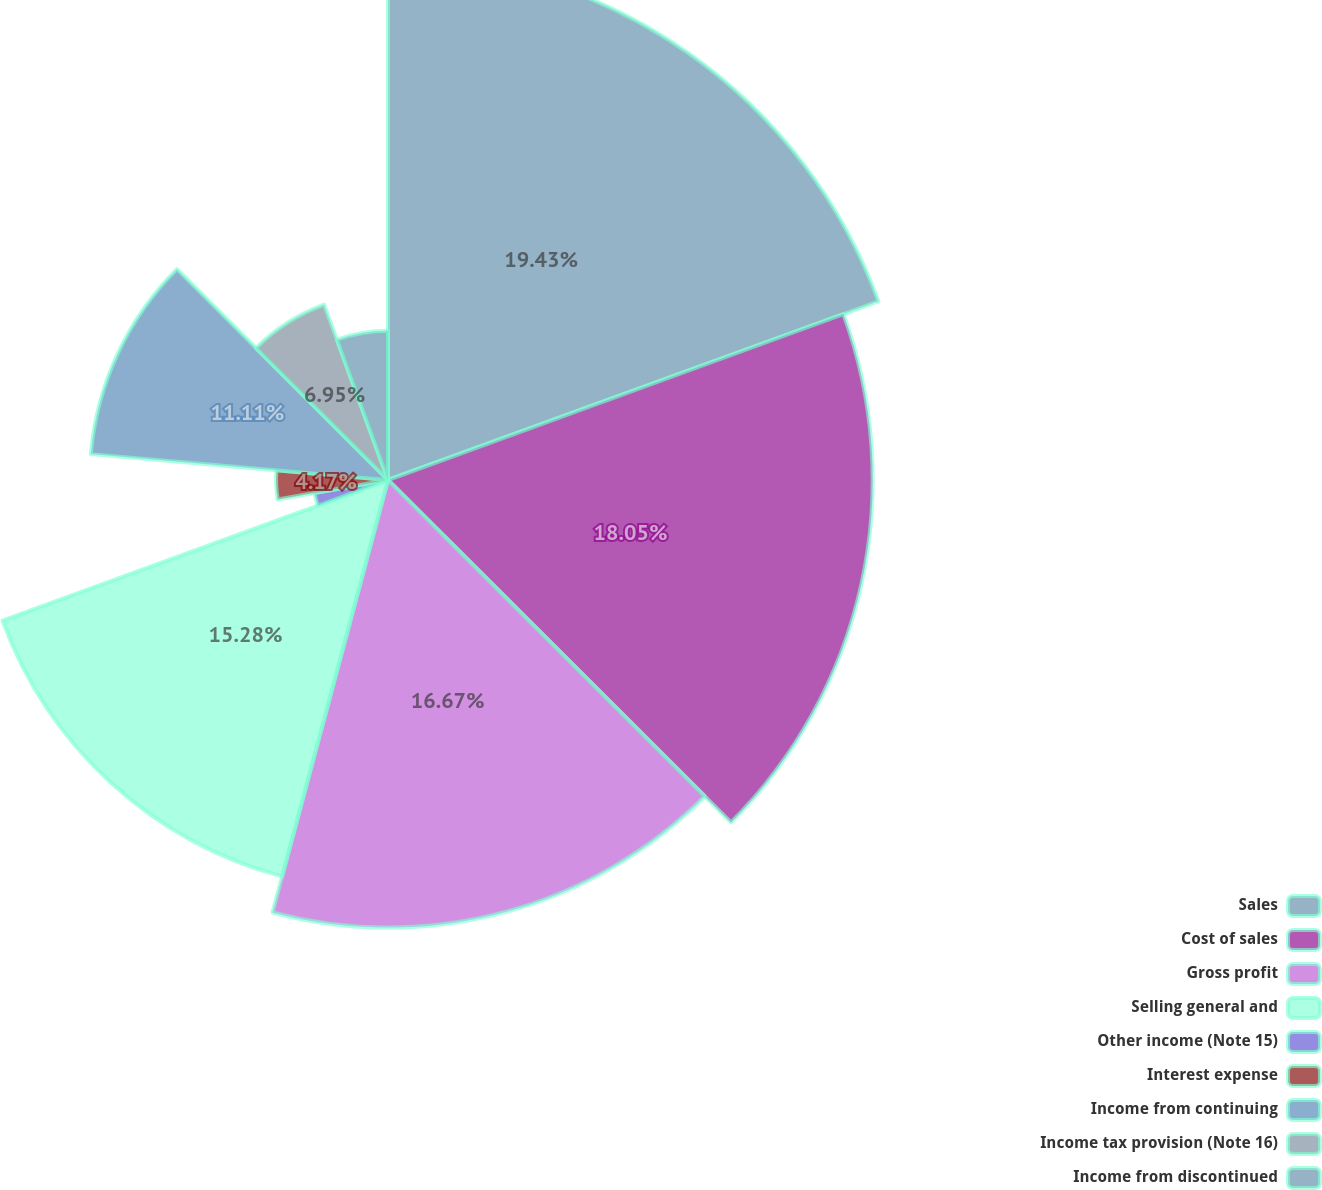Convert chart. <chart><loc_0><loc_0><loc_500><loc_500><pie_chart><fcel>Sales<fcel>Cost of sales<fcel>Gross profit<fcel>Selling general and<fcel>Other income (Note 15)<fcel>Interest expense<fcel>Income from continuing<fcel>Income tax provision (Note 16)<fcel>Income from discontinued<nl><fcel>19.44%<fcel>18.05%<fcel>16.67%<fcel>15.28%<fcel>2.78%<fcel>4.17%<fcel>11.11%<fcel>6.95%<fcel>5.56%<nl></chart> 